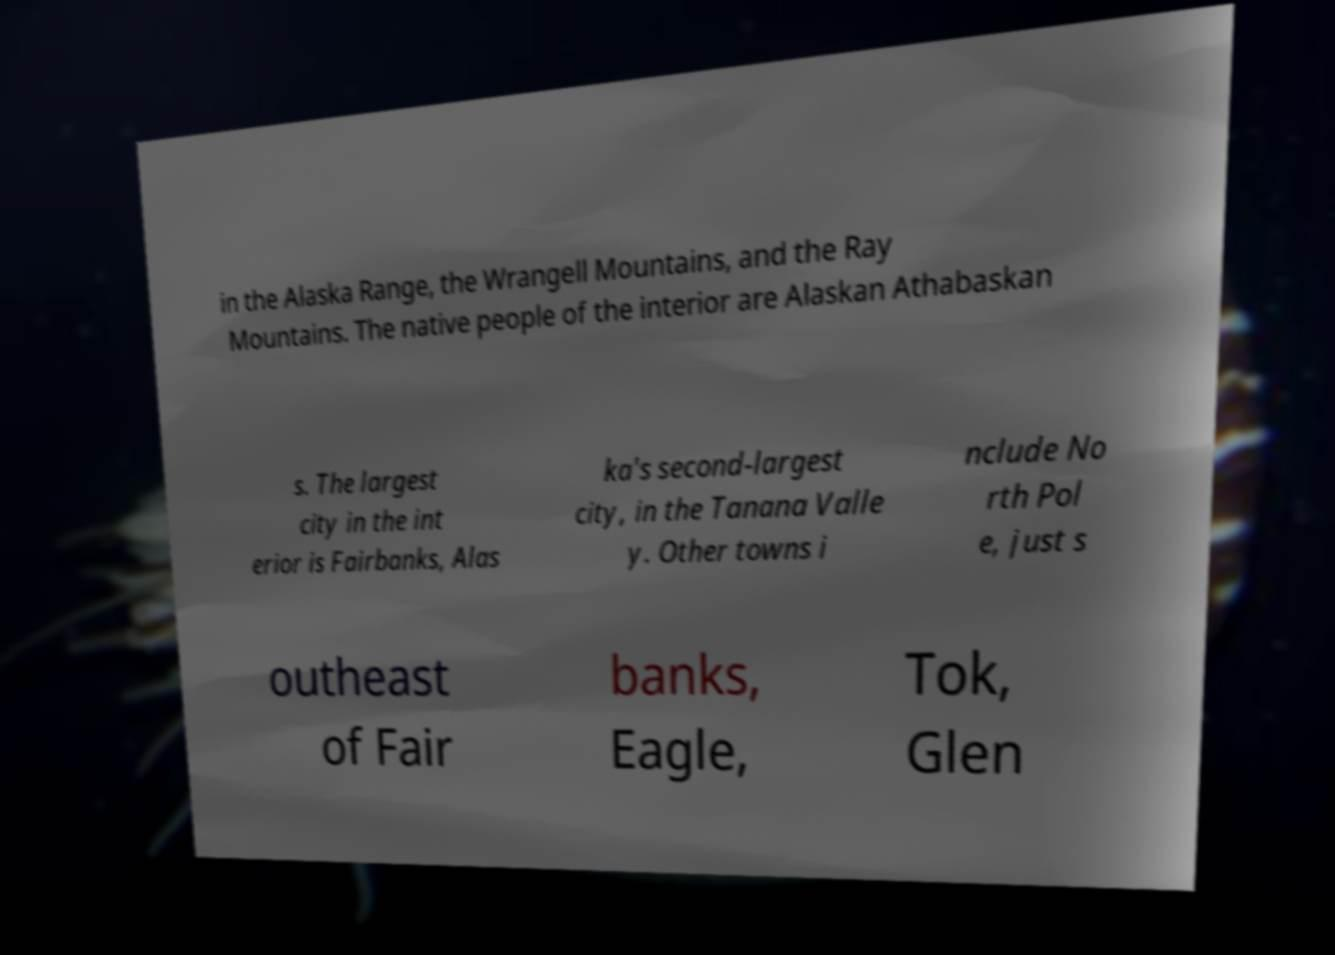Please identify and transcribe the text found in this image. in the Alaska Range, the Wrangell Mountains, and the Ray Mountains. The native people of the interior are Alaskan Athabaskan s. The largest city in the int erior is Fairbanks, Alas ka's second-largest city, in the Tanana Valle y. Other towns i nclude No rth Pol e, just s outheast of Fair banks, Eagle, Tok, Glen 